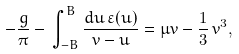Convert formula to latex. <formula><loc_0><loc_0><loc_500><loc_500>- \frac { g } { \pi } - \, \int _ { - B } ^ { B } \frac { d u \, \varepsilon ( u ) } { v - u } = \mu v - \frac { 1 } { 3 } \, v ^ { 3 } ,</formula> 